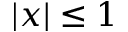Convert formula to latex. <formula><loc_0><loc_0><loc_500><loc_500>| x | \leq 1</formula> 